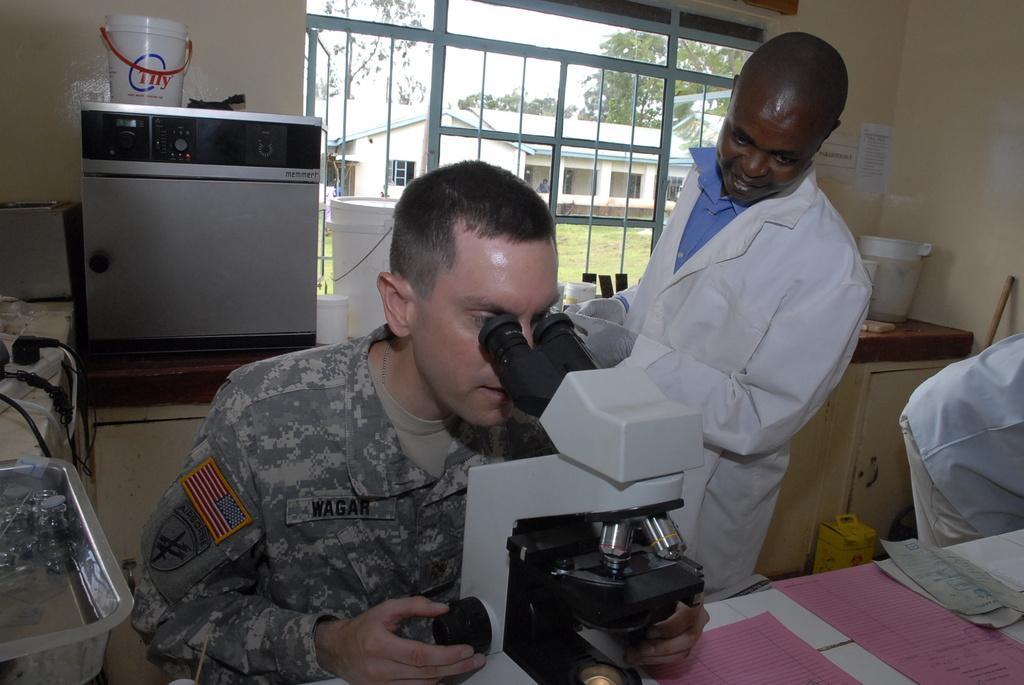Describe this image in one or two sentences. In the picture I can see a man wearing an army dress and looks like he is inspecting a sample piece in the microscope. I can see the papers on the table which is on the bottom right side of the picture. I can see another man on the right side is wearing a white coat and there are gloves in his hands. I can see a stainless steel bowl and cables on the table on the left side. I can see a plastic bucket on the washing machine which is on the top left side of the picture. In the background, I can see the metal grill fence, house and trees. 